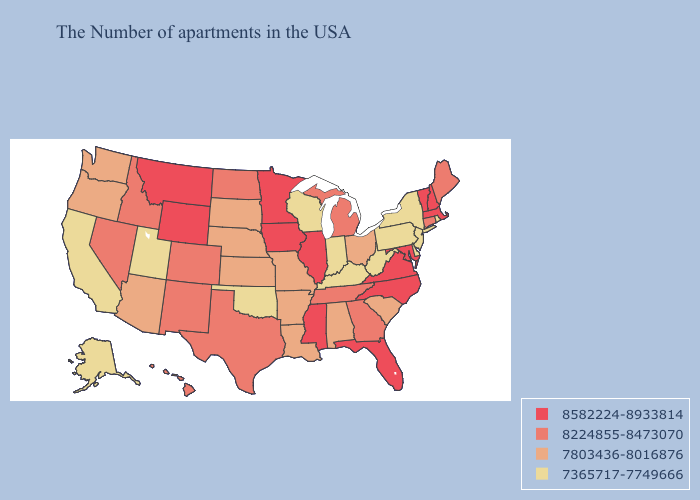What is the highest value in states that border Arizona?
Be succinct. 8224855-8473070. Name the states that have a value in the range 8582224-8933814?
Concise answer only. Massachusetts, New Hampshire, Vermont, Maryland, Virginia, North Carolina, Florida, Illinois, Mississippi, Minnesota, Iowa, Wyoming, Montana. Does Missouri have a higher value than Nebraska?
Keep it brief. No. Among the states that border New York , does Connecticut have the lowest value?
Answer briefly. No. Name the states that have a value in the range 8582224-8933814?
Concise answer only. Massachusetts, New Hampshire, Vermont, Maryland, Virginia, North Carolina, Florida, Illinois, Mississippi, Minnesota, Iowa, Wyoming, Montana. What is the value of Ohio?
Be succinct. 7803436-8016876. What is the value of Hawaii?
Concise answer only. 8224855-8473070. What is the value of Montana?
Quick response, please. 8582224-8933814. Does Massachusetts have the lowest value in the Northeast?
Write a very short answer. No. Name the states that have a value in the range 8224855-8473070?
Short answer required. Maine, Connecticut, Georgia, Michigan, Tennessee, Texas, North Dakota, Colorado, New Mexico, Idaho, Nevada, Hawaii. What is the highest value in the MidWest ?
Give a very brief answer. 8582224-8933814. Does Minnesota have the same value as New Jersey?
Keep it brief. No. What is the lowest value in the Northeast?
Keep it brief. 7365717-7749666. Name the states that have a value in the range 7365717-7749666?
Write a very short answer. Rhode Island, New York, New Jersey, Delaware, Pennsylvania, West Virginia, Kentucky, Indiana, Wisconsin, Oklahoma, Utah, California, Alaska. What is the lowest value in states that border Arkansas?
Write a very short answer. 7365717-7749666. 